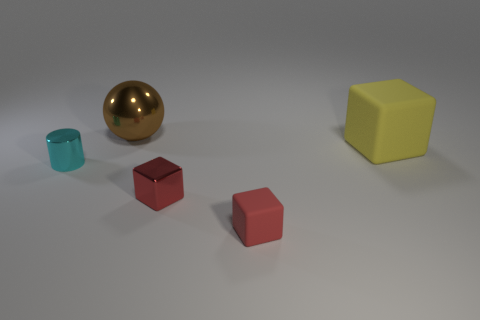Is there another tiny thing that has the same shape as the small cyan object?
Keep it short and to the point. No. Is the tiny rubber thing the same color as the tiny metallic cube?
Give a very brief answer. Yes. What material is the small object that is to the right of the red object behind the tiny matte cube?
Ensure brevity in your answer.  Rubber. The red metallic thing is what size?
Your response must be concise. Small. There is a red thing that is the same material as the cyan cylinder; what size is it?
Make the answer very short. Small. There is a block behind the cyan metallic cylinder; does it have the same size as the cyan thing?
Your answer should be very brief. No. What is the shape of the metal thing behind the tiny metallic thing that is left of the big shiny thing behind the red metal block?
Make the answer very short. Sphere. How many objects are blocks or shiny objects in front of the yellow thing?
Your answer should be compact. 4. How big is the metallic object right of the ball?
Make the answer very short. Small. There is another object that is the same color as the tiny rubber object; what shape is it?
Keep it short and to the point. Cube. 